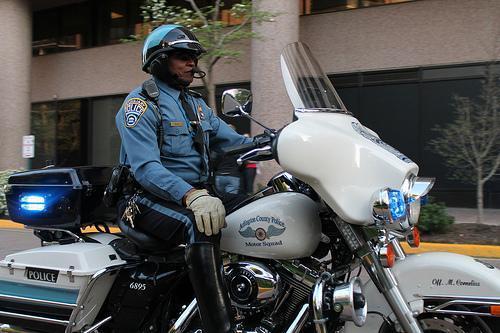How many motorbikes are in the photo?
Give a very brief answer. 1. 